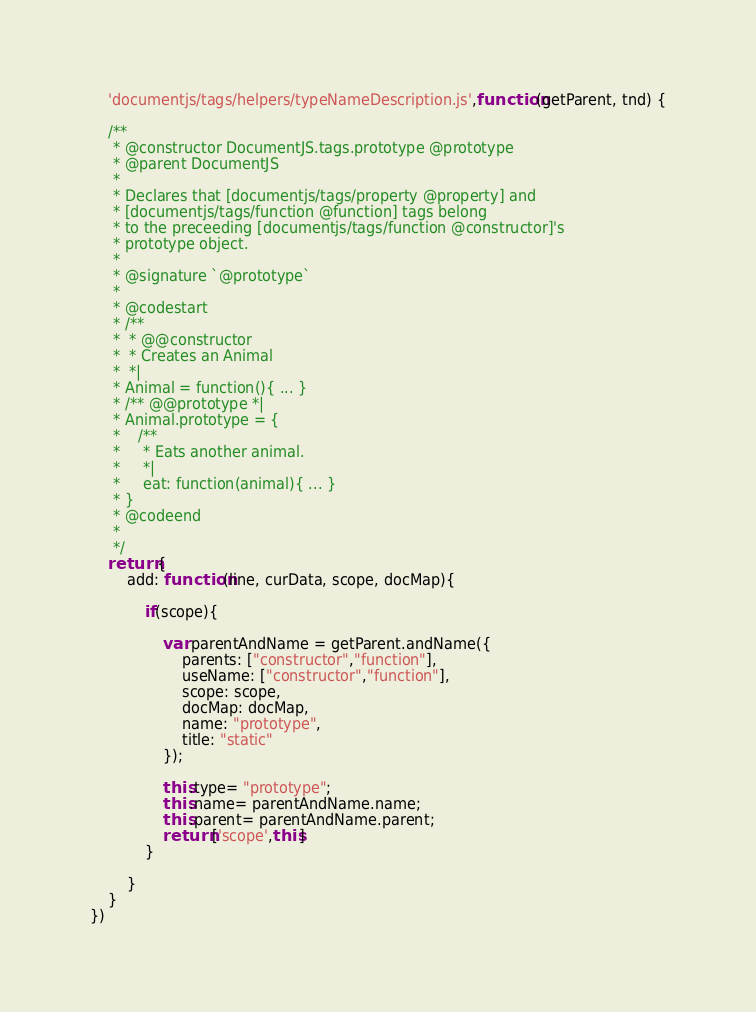<code> <loc_0><loc_0><loc_500><loc_500><_JavaScript_>	'documentjs/tags/helpers/typeNameDescription.js',function(getParent, tnd) {

	/**
	 * @constructor DocumentJS.tags.prototype @prototype
	 * @parent DocumentJS
	 * 
	 * Declares that [documentjs/tags/property @property] and
	 * [documentjs/tags/function @function] tags belong
	 * to the preceeding [documentjs/tags/function @constructor]'s
	 * prototype object.
	 * 
	 * @signature `@prototype`
	 * 
	 * @codestart
	 * /**
	 *  * @@constructor
	 *  * Creates an Animal
	 *  *|
	 * Animal = function(){ ... }
     * /** @@prototype *|
     * Animal.prototype = {
     *    /**
     *     * Eats another animal.
     *     *|
     *     eat: function(animal){ ... }
     * }
	 * @codeend
	 * 
	 */
	return {
		add: function(line, curData, scope, docMap){
			
			if(scope){
				
				var parentAndName = getParent.andName({
					parents: ["constructor","function"],
					useName: ["constructor","function"],
					scope: scope,
					docMap: docMap,
					name: "prototype",
					title: "static"
				});
				
				this.type= "prototype";
				this.name= parentAndName.name;
				this.parent= parentAndName.parent;
				return ['scope',this]
			}
			
		}
	}
})
</code> 